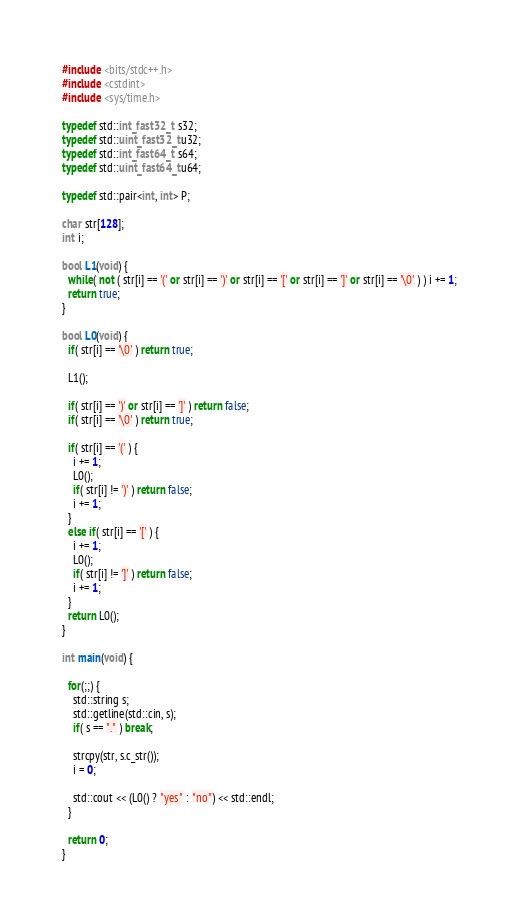<code> <loc_0><loc_0><loc_500><loc_500><_C++_>#include <bits/stdc++.h>
#include <cstdint>
#include <sys/time.h>

typedef std::int_fast32_t  s32;
typedef std::uint_fast32_t u32;
typedef std::int_fast64_t  s64;
typedef std::uint_fast64_t u64;

typedef std::pair<int, int> P;

char str[128];
int i;

bool L1(void) {
  while( not ( str[i] == '(' or str[i] == ')' or str[i] == '[' or str[i] == ']' or str[i] == '\0' ) ) i += 1;
  return true;
}

bool L0(void) {
  if( str[i] == '\0' ) return true;

  L1();

  if( str[i] == ')' or str[i] == ']' ) return false;
  if( str[i] == '\0' ) return true;
  
  if( str[i] == '(' ) {
    i += 1;
    L0();
    if( str[i] != ')' ) return false;
    i += 1;
  }
  else if( str[i] == '[' ) {
    i += 1;
    L0();
    if( str[i] != ']' ) return false;
    i += 1;
  }  
  return L0();
}

int main(void) {
  
  for(;;) {
    std::string s;
    std::getline(std::cin, s);
    if( s == "." ) break;

    strcpy(str, s.c_str());
    i = 0;

    std::cout << (L0() ? "yes" : "no") << std::endl;
  }
  
  return 0;
}</code> 